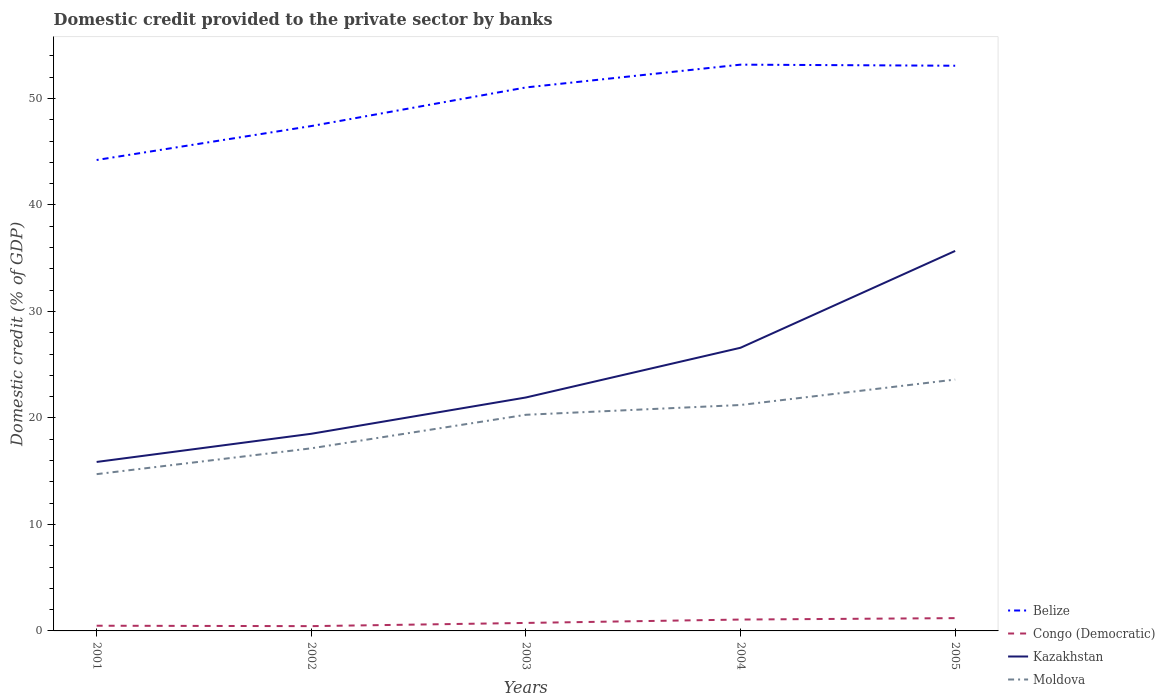How many different coloured lines are there?
Ensure brevity in your answer.  4. Does the line corresponding to Moldova intersect with the line corresponding to Belize?
Your answer should be compact. No. Across all years, what is the maximum domestic credit provided to the private sector by banks in Congo (Democratic)?
Provide a short and direct response. 0.45. What is the total domestic credit provided to the private sector by banks in Kazakhstan in the graph?
Provide a short and direct response. -6.05. What is the difference between the highest and the second highest domestic credit provided to the private sector by banks in Congo (Democratic)?
Provide a short and direct response. 0.75. What is the difference between the highest and the lowest domestic credit provided to the private sector by banks in Congo (Democratic)?
Your answer should be very brief. 2. How many lines are there?
Offer a terse response. 4. Are the values on the major ticks of Y-axis written in scientific E-notation?
Offer a terse response. No. Does the graph contain any zero values?
Your answer should be very brief. No. How many legend labels are there?
Ensure brevity in your answer.  4. What is the title of the graph?
Keep it short and to the point. Domestic credit provided to the private sector by banks. What is the label or title of the X-axis?
Make the answer very short. Years. What is the label or title of the Y-axis?
Ensure brevity in your answer.  Domestic credit (% of GDP). What is the Domestic credit (% of GDP) in Belize in 2001?
Keep it short and to the point. 44.22. What is the Domestic credit (% of GDP) in Congo (Democratic) in 2001?
Your response must be concise. 0.49. What is the Domestic credit (% of GDP) of Kazakhstan in 2001?
Offer a terse response. 15.87. What is the Domestic credit (% of GDP) in Moldova in 2001?
Your answer should be very brief. 14.72. What is the Domestic credit (% of GDP) of Belize in 2002?
Offer a terse response. 47.4. What is the Domestic credit (% of GDP) of Congo (Democratic) in 2002?
Ensure brevity in your answer.  0.45. What is the Domestic credit (% of GDP) of Kazakhstan in 2002?
Provide a succinct answer. 18.51. What is the Domestic credit (% of GDP) in Moldova in 2002?
Offer a very short reply. 17.15. What is the Domestic credit (% of GDP) of Belize in 2003?
Provide a succinct answer. 51.03. What is the Domestic credit (% of GDP) of Congo (Democratic) in 2003?
Your answer should be very brief. 0.75. What is the Domestic credit (% of GDP) of Kazakhstan in 2003?
Your answer should be compact. 21.92. What is the Domestic credit (% of GDP) of Moldova in 2003?
Your response must be concise. 20.29. What is the Domestic credit (% of GDP) of Belize in 2004?
Provide a short and direct response. 53.17. What is the Domestic credit (% of GDP) in Congo (Democratic) in 2004?
Offer a terse response. 1.07. What is the Domestic credit (% of GDP) in Kazakhstan in 2004?
Your response must be concise. 26.59. What is the Domestic credit (% of GDP) in Moldova in 2004?
Offer a very short reply. 21.21. What is the Domestic credit (% of GDP) in Belize in 2005?
Give a very brief answer. 53.07. What is the Domestic credit (% of GDP) of Congo (Democratic) in 2005?
Make the answer very short. 1.2. What is the Domestic credit (% of GDP) of Kazakhstan in 2005?
Offer a very short reply. 35.68. What is the Domestic credit (% of GDP) of Moldova in 2005?
Offer a very short reply. 23.6. Across all years, what is the maximum Domestic credit (% of GDP) in Belize?
Provide a succinct answer. 53.17. Across all years, what is the maximum Domestic credit (% of GDP) of Congo (Democratic)?
Keep it short and to the point. 1.2. Across all years, what is the maximum Domestic credit (% of GDP) in Kazakhstan?
Offer a very short reply. 35.68. Across all years, what is the maximum Domestic credit (% of GDP) of Moldova?
Provide a succinct answer. 23.6. Across all years, what is the minimum Domestic credit (% of GDP) of Belize?
Your answer should be very brief. 44.22. Across all years, what is the minimum Domestic credit (% of GDP) of Congo (Democratic)?
Provide a short and direct response. 0.45. Across all years, what is the minimum Domestic credit (% of GDP) in Kazakhstan?
Provide a short and direct response. 15.87. Across all years, what is the minimum Domestic credit (% of GDP) in Moldova?
Provide a short and direct response. 14.72. What is the total Domestic credit (% of GDP) in Belize in the graph?
Provide a short and direct response. 248.89. What is the total Domestic credit (% of GDP) in Congo (Democratic) in the graph?
Keep it short and to the point. 3.96. What is the total Domestic credit (% of GDP) of Kazakhstan in the graph?
Offer a terse response. 118.56. What is the total Domestic credit (% of GDP) in Moldova in the graph?
Your answer should be compact. 96.97. What is the difference between the Domestic credit (% of GDP) of Belize in 2001 and that in 2002?
Offer a terse response. -3.19. What is the difference between the Domestic credit (% of GDP) in Congo (Democratic) in 2001 and that in 2002?
Provide a succinct answer. 0.04. What is the difference between the Domestic credit (% of GDP) of Kazakhstan in 2001 and that in 2002?
Provide a succinct answer. -2.65. What is the difference between the Domestic credit (% of GDP) in Moldova in 2001 and that in 2002?
Provide a short and direct response. -2.43. What is the difference between the Domestic credit (% of GDP) in Belize in 2001 and that in 2003?
Offer a terse response. -6.81. What is the difference between the Domestic credit (% of GDP) of Congo (Democratic) in 2001 and that in 2003?
Keep it short and to the point. -0.26. What is the difference between the Domestic credit (% of GDP) of Kazakhstan in 2001 and that in 2003?
Provide a succinct answer. -6.05. What is the difference between the Domestic credit (% of GDP) in Moldova in 2001 and that in 2003?
Your response must be concise. -5.57. What is the difference between the Domestic credit (% of GDP) in Belize in 2001 and that in 2004?
Your answer should be very brief. -8.95. What is the difference between the Domestic credit (% of GDP) in Congo (Democratic) in 2001 and that in 2004?
Your answer should be compact. -0.58. What is the difference between the Domestic credit (% of GDP) of Kazakhstan in 2001 and that in 2004?
Provide a succinct answer. -10.72. What is the difference between the Domestic credit (% of GDP) in Moldova in 2001 and that in 2004?
Make the answer very short. -6.49. What is the difference between the Domestic credit (% of GDP) in Belize in 2001 and that in 2005?
Your answer should be compact. -8.85. What is the difference between the Domestic credit (% of GDP) of Congo (Democratic) in 2001 and that in 2005?
Make the answer very short. -0.71. What is the difference between the Domestic credit (% of GDP) of Kazakhstan in 2001 and that in 2005?
Your answer should be very brief. -19.81. What is the difference between the Domestic credit (% of GDP) of Moldova in 2001 and that in 2005?
Your response must be concise. -8.88. What is the difference between the Domestic credit (% of GDP) of Belize in 2002 and that in 2003?
Offer a very short reply. -3.63. What is the difference between the Domestic credit (% of GDP) in Congo (Democratic) in 2002 and that in 2003?
Offer a very short reply. -0.3. What is the difference between the Domestic credit (% of GDP) in Kazakhstan in 2002 and that in 2003?
Provide a short and direct response. -3.41. What is the difference between the Domestic credit (% of GDP) of Moldova in 2002 and that in 2003?
Provide a succinct answer. -3.15. What is the difference between the Domestic credit (% of GDP) of Belize in 2002 and that in 2004?
Your response must be concise. -5.77. What is the difference between the Domestic credit (% of GDP) in Congo (Democratic) in 2002 and that in 2004?
Your response must be concise. -0.62. What is the difference between the Domestic credit (% of GDP) in Kazakhstan in 2002 and that in 2004?
Your answer should be very brief. -8.08. What is the difference between the Domestic credit (% of GDP) in Moldova in 2002 and that in 2004?
Give a very brief answer. -4.07. What is the difference between the Domestic credit (% of GDP) in Belize in 2002 and that in 2005?
Make the answer very short. -5.66. What is the difference between the Domestic credit (% of GDP) in Congo (Democratic) in 2002 and that in 2005?
Offer a terse response. -0.75. What is the difference between the Domestic credit (% of GDP) of Kazakhstan in 2002 and that in 2005?
Make the answer very short. -17.17. What is the difference between the Domestic credit (% of GDP) of Moldova in 2002 and that in 2005?
Offer a terse response. -6.46. What is the difference between the Domestic credit (% of GDP) of Belize in 2003 and that in 2004?
Offer a terse response. -2.14. What is the difference between the Domestic credit (% of GDP) in Congo (Democratic) in 2003 and that in 2004?
Keep it short and to the point. -0.32. What is the difference between the Domestic credit (% of GDP) in Kazakhstan in 2003 and that in 2004?
Keep it short and to the point. -4.67. What is the difference between the Domestic credit (% of GDP) of Moldova in 2003 and that in 2004?
Provide a short and direct response. -0.92. What is the difference between the Domestic credit (% of GDP) in Belize in 2003 and that in 2005?
Provide a short and direct response. -2.04. What is the difference between the Domestic credit (% of GDP) in Congo (Democratic) in 2003 and that in 2005?
Make the answer very short. -0.45. What is the difference between the Domestic credit (% of GDP) in Kazakhstan in 2003 and that in 2005?
Offer a terse response. -13.76. What is the difference between the Domestic credit (% of GDP) of Moldova in 2003 and that in 2005?
Provide a short and direct response. -3.31. What is the difference between the Domestic credit (% of GDP) of Belize in 2004 and that in 2005?
Your response must be concise. 0.1. What is the difference between the Domestic credit (% of GDP) in Congo (Democratic) in 2004 and that in 2005?
Make the answer very short. -0.13. What is the difference between the Domestic credit (% of GDP) in Kazakhstan in 2004 and that in 2005?
Provide a succinct answer. -9.09. What is the difference between the Domestic credit (% of GDP) in Moldova in 2004 and that in 2005?
Ensure brevity in your answer.  -2.39. What is the difference between the Domestic credit (% of GDP) in Belize in 2001 and the Domestic credit (% of GDP) in Congo (Democratic) in 2002?
Your answer should be very brief. 43.77. What is the difference between the Domestic credit (% of GDP) in Belize in 2001 and the Domestic credit (% of GDP) in Kazakhstan in 2002?
Ensure brevity in your answer.  25.71. What is the difference between the Domestic credit (% of GDP) in Belize in 2001 and the Domestic credit (% of GDP) in Moldova in 2002?
Offer a terse response. 27.07. What is the difference between the Domestic credit (% of GDP) in Congo (Democratic) in 2001 and the Domestic credit (% of GDP) in Kazakhstan in 2002?
Offer a very short reply. -18.02. What is the difference between the Domestic credit (% of GDP) in Congo (Democratic) in 2001 and the Domestic credit (% of GDP) in Moldova in 2002?
Ensure brevity in your answer.  -16.66. What is the difference between the Domestic credit (% of GDP) of Kazakhstan in 2001 and the Domestic credit (% of GDP) of Moldova in 2002?
Your response must be concise. -1.28. What is the difference between the Domestic credit (% of GDP) of Belize in 2001 and the Domestic credit (% of GDP) of Congo (Democratic) in 2003?
Keep it short and to the point. 43.47. What is the difference between the Domestic credit (% of GDP) in Belize in 2001 and the Domestic credit (% of GDP) in Kazakhstan in 2003?
Make the answer very short. 22.3. What is the difference between the Domestic credit (% of GDP) of Belize in 2001 and the Domestic credit (% of GDP) of Moldova in 2003?
Provide a short and direct response. 23.92. What is the difference between the Domestic credit (% of GDP) in Congo (Democratic) in 2001 and the Domestic credit (% of GDP) in Kazakhstan in 2003?
Your response must be concise. -21.43. What is the difference between the Domestic credit (% of GDP) in Congo (Democratic) in 2001 and the Domestic credit (% of GDP) in Moldova in 2003?
Your answer should be very brief. -19.81. What is the difference between the Domestic credit (% of GDP) of Kazakhstan in 2001 and the Domestic credit (% of GDP) of Moldova in 2003?
Your response must be concise. -4.43. What is the difference between the Domestic credit (% of GDP) of Belize in 2001 and the Domestic credit (% of GDP) of Congo (Democratic) in 2004?
Provide a short and direct response. 43.15. What is the difference between the Domestic credit (% of GDP) in Belize in 2001 and the Domestic credit (% of GDP) in Kazakhstan in 2004?
Your answer should be compact. 17.63. What is the difference between the Domestic credit (% of GDP) in Belize in 2001 and the Domestic credit (% of GDP) in Moldova in 2004?
Your answer should be compact. 23. What is the difference between the Domestic credit (% of GDP) of Congo (Democratic) in 2001 and the Domestic credit (% of GDP) of Kazakhstan in 2004?
Give a very brief answer. -26.1. What is the difference between the Domestic credit (% of GDP) in Congo (Democratic) in 2001 and the Domestic credit (% of GDP) in Moldova in 2004?
Keep it short and to the point. -20.72. What is the difference between the Domestic credit (% of GDP) of Kazakhstan in 2001 and the Domestic credit (% of GDP) of Moldova in 2004?
Provide a succinct answer. -5.35. What is the difference between the Domestic credit (% of GDP) of Belize in 2001 and the Domestic credit (% of GDP) of Congo (Democratic) in 2005?
Give a very brief answer. 43.02. What is the difference between the Domestic credit (% of GDP) of Belize in 2001 and the Domestic credit (% of GDP) of Kazakhstan in 2005?
Your response must be concise. 8.54. What is the difference between the Domestic credit (% of GDP) of Belize in 2001 and the Domestic credit (% of GDP) of Moldova in 2005?
Offer a terse response. 20.62. What is the difference between the Domestic credit (% of GDP) of Congo (Democratic) in 2001 and the Domestic credit (% of GDP) of Kazakhstan in 2005?
Your answer should be compact. -35.19. What is the difference between the Domestic credit (% of GDP) in Congo (Democratic) in 2001 and the Domestic credit (% of GDP) in Moldova in 2005?
Ensure brevity in your answer.  -23.11. What is the difference between the Domestic credit (% of GDP) in Kazakhstan in 2001 and the Domestic credit (% of GDP) in Moldova in 2005?
Provide a short and direct response. -7.74. What is the difference between the Domestic credit (% of GDP) of Belize in 2002 and the Domestic credit (% of GDP) of Congo (Democratic) in 2003?
Ensure brevity in your answer.  46.65. What is the difference between the Domestic credit (% of GDP) of Belize in 2002 and the Domestic credit (% of GDP) of Kazakhstan in 2003?
Provide a short and direct response. 25.48. What is the difference between the Domestic credit (% of GDP) of Belize in 2002 and the Domestic credit (% of GDP) of Moldova in 2003?
Provide a short and direct response. 27.11. What is the difference between the Domestic credit (% of GDP) of Congo (Democratic) in 2002 and the Domestic credit (% of GDP) of Kazakhstan in 2003?
Keep it short and to the point. -21.47. What is the difference between the Domestic credit (% of GDP) of Congo (Democratic) in 2002 and the Domestic credit (% of GDP) of Moldova in 2003?
Provide a succinct answer. -19.85. What is the difference between the Domestic credit (% of GDP) of Kazakhstan in 2002 and the Domestic credit (% of GDP) of Moldova in 2003?
Ensure brevity in your answer.  -1.78. What is the difference between the Domestic credit (% of GDP) in Belize in 2002 and the Domestic credit (% of GDP) in Congo (Democratic) in 2004?
Your response must be concise. 46.34. What is the difference between the Domestic credit (% of GDP) in Belize in 2002 and the Domestic credit (% of GDP) in Kazakhstan in 2004?
Your answer should be very brief. 20.82. What is the difference between the Domestic credit (% of GDP) in Belize in 2002 and the Domestic credit (% of GDP) in Moldova in 2004?
Offer a terse response. 26.19. What is the difference between the Domestic credit (% of GDP) of Congo (Democratic) in 2002 and the Domestic credit (% of GDP) of Kazakhstan in 2004?
Offer a terse response. -26.14. What is the difference between the Domestic credit (% of GDP) of Congo (Democratic) in 2002 and the Domestic credit (% of GDP) of Moldova in 2004?
Ensure brevity in your answer.  -20.76. What is the difference between the Domestic credit (% of GDP) of Kazakhstan in 2002 and the Domestic credit (% of GDP) of Moldova in 2004?
Your answer should be very brief. -2.7. What is the difference between the Domestic credit (% of GDP) in Belize in 2002 and the Domestic credit (% of GDP) in Congo (Democratic) in 2005?
Your answer should be compact. 46.2. What is the difference between the Domestic credit (% of GDP) in Belize in 2002 and the Domestic credit (% of GDP) in Kazakhstan in 2005?
Provide a short and direct response. 11.72. What is the difference between the Domestic credit (% of GDP) in Belize in 2002 and the Domestic credit (% of GDP) in Moldova in 2005?
Offer a very short reply. 23.8. What is the difference between the Domestic credit (% of GDP) of Congo (Democratic) in 2002 and the Domestic credit (% of GDP) of Kazakhstan in 2005?
Make the answer very short. -35.23. What is the difference between the Domestic credit (% of GDP) in Congo (Democratic) in 2002 and the Domestic credit (% of GDP) in Moldova in 2005?
Offer a very short reply. -23.15. What is the difference between the Domestic credit (% of GDP) of Kazakhstan in 2002 and the Domestic credit (% of GDP) of Moldova in 2005?
Offer a very short reply. -5.09. What is the difference between the Domestic credit (% of GDP) of Belize in 2003 and the Domestic credit (% of GDP) of Congo (Democratic) in 2004?
Provide a short and direct response. 49.96. What is the difference between the Domestic credit (% of GDP) in Belize in 2003 and the Domestic credit (% of GDP) in Kazakhstan in 2004?
Your response must be concise. 24.44. What is the difference between the Domestic credit (% of GDP) in Belize in 2003 and the Domestic credit (% of GDP) in Moldova in 2004?
Offer a very short reply. 29.82. What is the difference between the Domestic credit (% of GDP) in Congo (Democratic) in 2003 and the Domestic credit (% of GDP) in Kazakhstan in 2004?
Give a very brief answer. -25.84. What is the difference between the Domestic credit (% of GDP) in Congo (Democratic) in 2003 and the Domestic credit (% of GDP) in Moldova in 2004?
Your answer should be very brief. -20.46. What is the difference between the Domestic credit (% of GDP) of Kazakhstan in 2003 and the Domestic credit (% of GDP) of Moldova in 2004?
Your response must be concise. 0.71. What is the difference between the Domestic credit (% of GDP) in Belize in 2003 and the Domestic credit (% of GDP) in Congo (Democratic) in 2005?
Your answer should be compact. 49.83. What is the difference between the Domestic credit (% of GDP) in Belize in 2003 and the Domestic credit (% of GDP) in Kazakhstan in 2005?
Offer a terse response. 15.35. What is the difference between the Domestic credit (% of GDP) in Belize in 2003 and the Domestic credit (% of GDP) in Moldova in 2005?
Offer a very short reply. 27.43. What is the difference between the Domestic credit (% of GDP) of Congo (Democratic) in 2003 and the Domestic credit (% of GDP) of Kazakhstan in 2005?
Provide a short and direct response. -34.93. What is the difference between the Domestic credit (% of GDP) of Congo (Democratic) in 2003 and the Domestic credit (% of GDP) of Moldova in 2005?
Give a very brief answer. -22.85. What is the difference between the Domestic credit (% of GDP) in Kazakhstan in 2003 and the Domestic credit (% of GDP) in Moldova in 2005?
Make the answer very short. -1.68. What is the difference between the Domestic credit (% of GDP) in Belize in 2004 and the Domestic credit (% of GDP) in Congo (Democratic) in 2005?
Give a very brief answer. 51.97. What is the difference between the Domestic credit (% of GDP) of Belize in 2004 and the Domestic credit (% of GDP) of Kazakhstan in 2005?
Offer a very short reply. 17.49. What is the difference between the Domestic credit (% of GDP) in Belize in 2004 and the Domestic credit (% of GDP) in Moldova in 2005?
Keep it short and to the point. 29.57. What is the difference between the Domestic credit (% of GDP) in Congo (Democratic) in 2004 and the Domestic credit (% of GDP) in Kazakhstan in 2005?
Keep it short and to the point. -34.61. What is the difference between the Domestic credit (% of GDP) of Congo (Democratic) in 2004 and the Domestic credit (% of GDP) of Moldova in 2005?
Provide a succinct answer. -22.53. What is the difference between the Domestic credit (% of GDP) of Kazakhstan in 2004 and the Domestic credit (% of GDP) of Moldova in 2005?
Ensure brevity in your answer.  2.99. What is the average Domestic credit (% of GDP) of Belize per year?
Ensure brevity in your answer.  49.78. What is the average Domestic credit (% of GDP) in Congo (Democratic) per year?
Your answer should be very brief. 0.79. What is the average Domestic credit (% of GDP) in Kazakhstan per year?
Your answer should be very brief. 23.71. What is the average Domestic credit (% of GDP) in Moldova per year?
Offer a terse response. 19.39. In the year 2001, what is the difference between the Domestic credit (% of GDP) in Belize and Domestic credit (% of GDP) in Congo (Democratic)?
Offer a very short reply. 43.73. In the year 2001, what is the difference between the Domestic credit (% of GDP) of Belize and Domestic credit (% of GDP) of Kazakhstan?
Offer a terse response. 28.35. In the year 2001, what is the difference between the Domestic credit (% of GDP) in Belize and Domestic credit (% of GDP) in Moldova?
Your answer should be very brief. 29.5. In the year 2001, what is the difference between the Domestic credit (% of GDP) in Congo (Democratic) and Domestic credit (% of GDP) in Kazakhstan?
Your answer should be compact. -15.38. In the year 2001, what is the difference between the Domestic credit (% of GDP) in Congo (Democratic) and Domestic credit (% of GDP) in Moldova?
Provide a short and direct response. -14.23. In the year 2001, what is the difference between the Domestic credit (% of GDP) of Kazakhstan and Domestic credit (% of GDP) of Moldova?
Your answer should be compact. 1.15. In the year 2002, what is the difference between the Domestic credit (% of GDP) of Belize and Domestic credit (% of GDP) of Congo (Democratic)?
Give a very brief answer. 46.95. In the year 2002, what is the difference between the Domestic credit (% of GDP) in Belize and Domestic credit (% of GDP) in Kazakhstan?
Provide a short and direct response. 28.89. In the year 2002, what is the difference between the Domestic credit (% of GDP) of Belize and Domestic credit (% of GDP) of Moldova?
Provide a short and direct response. 30.26. In the year 2002, what is the difference between the Domestic credit (% of GDP) in Congo (Democratic) and Domestic credit (% of GDP) in Kazakhstan?
Provide a short and direct response. -18.06. In the year 2002, what is the difference between the Domestic credit (% of GDP) of Congo (Democratic) and Domestic credit (% of GDP) of Moldova?
Make the answer very short. -16.7. In the year 2002, what is the difference between the Domestic credit (% of GDP) in Kazakhstan and Domestic credit (% of GDP) in Moldova?
Your answer should be compact. 1.37. In the year 2003, what is the difference between the Domestic credit (% of GDP) in Belize and Domestic credit (% of GDP) in Congo (Democratic)?
Provide a short and direct response. 50.28. In the year 2003, what is the difference between the Domestic credit (% of GDP) of Belize and Domestic credit (% of GDP) of Kazakhstan?
Offer a very short reply. 29.11. In the year 2003, what is the difference between the Domestic credit (% of GDP) of Belize and Domestic credit (% of GDP) of Moldova?
Your answer should be compact. 30.74. In the year 2003, what is the difference between the Domestic credit (% of GDP) of Congo (Democratic) and Domestic credit (% of GDP) of Kazakhstan?
Provide a succinct answer. -21.17. In the year 2003, what is the difference between the Domestic credit (% of GDP) in Congo (Democratic) and Domestic credit (% of GDP) in Moldova?
Keep it short and to the point. -19.54. In the year 2003, what is the difference between the Domestic credit (% of GDP) of Kazakhstan and Domestic credit (% of GDP) of Moldova?
Give a very brief answer. 1.62. In the year 2004, what is the difference between the Domestic credit (% of GDP) in Belize and Domestic credit (% of GDP) in Congo (Democratic)?
Your answer should be compact. 52.1. In the year 2004, what is the difference between the Domestic credit (% of GDP) of Belize and Domestic credit (% of GDP) of Kazakhstan?
Your answer should be compact. 26.58. In the year 2004, what is the difference between the Domestic credit (% of GDP) in Belize and Domestic credit (% of GDP) in Moldova?
Offer a very short reply. 31.96. In the year 2004, what is the difference between the Domestic credit (% of GDP) in Congo (Democratic) and Domestic credit (% of GDP) in Kazakhstan?
Your answer should be compact. -25.52. In the year 2004, what is the difference between the Domestic credit (% of GDP) of Congo (Democratic) and Domestic credit (% of GDP) of Moldova?
Your response must be concise. -20.14. In the year 2004, what is the difference between the Domestic credit (% of GDP) of Kazakhstan and Domestic credit (% of GDP) of Moldova?
Keep it short and to the point. 5.37. In the year 2005, what is the difference between the Domestic credit (% of GDP) of Belize and Domestic credit (% of GDP) of Congo (Democratic)?
Give a very brief answer. 51.87. In the year 2005, what is the difference between the Domestic credit (% of GDP) in Belize and Domestic credit (% of GDP) in Kazakhstan?
Your answer should be compact. 17.39. In the year 2005, what is the difference between the Domestic credit (% of GDP) in Belize and Domestic credit (% of GDP) in Moldova?
Provide a succinct answer. 29.47. In the year 2005, what is the difference between the Domestic credit (% of GDP) in Congo (Democratic) and Domestic credit (% of GDP) in Kazakhstan?
Offer a very short reply. -34.48. In the year 2005, what is the difference between the Domestic credit (% of GDP) in Congo (Democratic) and Domestic credit (% of GDP) in Moldova?
Your response must be concise. -22.4. In the year 2005, what is the difference between the Domestic credit (% of GDP) of Kazakhstan and Domestic credit (% of GDP) of Moldova?
Your answer should be compact. 12.08. What is the ratio of the Domestic credit (% of GDP) of Belize in 2001 to that in 2002?
Give a very brief answer. 0.93. What is the ratio of the Domestic credit (% of GDP) in Congo (Democratic) in 2001 to that in 2002?
Provide a short and direct response. 1.09. What is the ratio of the Domestic credit (% of GDP) in Kazakhstan in 2001 to that in 2002?
Provide a short and direct response. 0.86. What is the ratio of the Domestic credit (% of GDP) in Moldova in 2001 to that in 2002?
Offer a very short reply. 0.86. What is the ratio of the Domestic credit (% of GDP) of Belize in 2001 to that in 2003?
Offer a terse response. 0.87. What is the ratio of the Domestic credit (% of GDP) in Congo (Democratic) in 2001 to that in 2003?
Give a very brief answer. 0.65. What is the ratio of the Domestic credit (% of GDP) of Kazakhstan in 2001 to that in 2003?
Offer a very short reply. 0.72. What is the ratio of the Domestic credit (% of GDP) in Moldova in 2001 to that in 2003?
Offer a terse response. 0.73. What is the ratio of the Domestic credit (% of GDP) of Belize in 2001 to that in 2004?
Give a very brief answer. 0.83. What is the ratio of the Domestic credit (% of GDP) of Congo (Democratic) in 2001 to that in 2004?
Your answer should be very brief. 0.46. What is the ratio of the Domestic credit (% of GDP) in Kazakhstan in 2001 to that in 2004?
Make the answer very short. 0.6. What is the ratio of the Domestic credit (% of GDP) in Moldova in 2001 to that in 2004?
Make the answer very short. 0.69. What is the ratio of the Domestic credit (% of GDP) of Belize in 2001 to that in 2005?
Offer a terse response. 0.83. What is the ratio of the Domestic credit (% of GDP) of Congo (Democratic) in 2001 to that in 2005?
Your answer should be very brief. 0.41. What is the ratio of the Domestic credit (% of GDP) in Kazakhstan in 2001 to that in 2005?
Provide a succinct answer. 0.44. What is the ratio of the Domestic credit (% of GDP) of Moldova in 2001 to that in 2005?
Provide a succinct answer. 0.62. What is the ratio of the Domestic credit (% of GDP) of Belize in 2002 to that in 2003?
Provide a short and direct response. 0.93. What is the ratio of the Domestic credit (% of GDP) in Congo (Democratic) in 2002 to that in 2003?
Keep it short and to the point. 0.6. What is the ratio of the Domestic credit (% of GDP) in Kazakhstan in 2002 to that in 2003?
Ensure brevity in your answer.  0.84. What is the ratio of the Domestic credit (% of GDP) in Moldova in 2002 to that in 2003?
Provide a short and direct response. 0.84. What is the ratio of the Domestic credit (% of GDP) in Belize in 2002 to that in 2004?
Make the answer very short. 0.89. What is the ratio of the Domestic credit (% of GDP) of Congo (Democratic) in 2002 to that in 2004?
Provide a short and direct response. 0.42. What is the ratio of the Domestic credit (% of GDP) of Kazakhstan in 2002 to that in 2004?
Your answer should be compact. 0.7. What is the ratio of the Domestic credit (% of GDP) of Moldova in 2002 to that in 2004?
Provide a short and direct response. 0.81. What is the ratio of the Domestic credit (% of GDP) of Belize in 2002 to that in 2005?
Keep it short and to the point. 0.89. What is the ratio of the Domestic credit (% of GDP) in Congo (Democratic) in 2002 to that in 2005?
Provide a short and direct response. 0.37. What is the ratio of the Domestic credit (% of GDP) of Kazakhstan in 2002 to that in 2005?
Provide a succinct answer. 0.52. What is the ratio of the Domestic credit (% of GDP) in Moldova in 2002 to that in 2005?
Your answer should be compact. 0.73. What is the ratio of the Domestic credit (% of GDP) in Belize in 2003 to that in 2004?
Your answer should be compact. 0.96. What is the ratio of the Domestic credit (% of GDP) in Congo (Democratic) in 2003 to that in 2004?
Offer a terse response. 0.7. What is the ratio of the Domestic credit (% of GDP) of Kazakhstan in 2003 to that in 2004?
Make the answer very short. 0.82. What is the ratio of the Domestic credit (% of GDP) in Moldova in 2003 to that in 2004?
Your response must be concise. 0.96. What is the ratio of the Domestic credit (% of GDP) in Belize in 2003 to that in 2005?
Provide a short and direct response. 0.96. What is the ratio of the Domestic credit (% of GDP) in Congo (Democratic) in 2003 to that in 2005?
Provide a succinct answer. 0.62. What is the ratio of the Domestic credit (% of GDP) in Kazakhstan in 2003 to that in 2005?
Your answer should be very brief. 0.61. What is the ratio of the Domestic credit (% of GDP) of Moldova in 2003 to that in 2005?
Offer a very short reply. 0.86. What is the ratio of the Domestic credit (% of GDP) of Congo (Democratic) in 2004 to that in 2005?
Your answer should be very brief. 0.89. What is the ratio of the Domestic credit (% of GDP) in Kazakhstan in 2004 to that in 2005?
Your answer should be compact. 0.75. What is the ratio of the Domestic credit (% of GDP) of Moldova in 2004 to that in 2005?
Offer a terse response. 0.9. What is the difference between the highest and the second highest Domestic credit (% of GDP) in Belize?
Offer a terse response. 0.1. What is the difference between the highest and the second highest Domestic credit (% of GDP) of Congo (Democratic)?
Your response must be concise. 0.13. What is the difference between the highest and the second highest Domestic credit (% of GDP) in Kazakhstan?
Ensure brevity in your answer.  9.09. What is the difference between the highest and the second highest Domestic credit (% of GDP) in Moldova?
Give a very brief answer. 2.39. What is the difference between the highest and the lowest Domestic credit (% of GDP) in Belize?
Your answer should be very brief. 8.95. What is the difference between the highest and the lowest Domestic credit (% of GDP) of Congo (Democratic)?
Provide a short and direct response. 0.75. What is the difference between the highest and the lowest Domestic credit (% of GDP) in Kazakhstan?
Your response must be concise. 19.81. What is the difference between the highest and the lowest Domestic credit (% of GDP) of Moldova?
Your response must be concise. 8.88. 